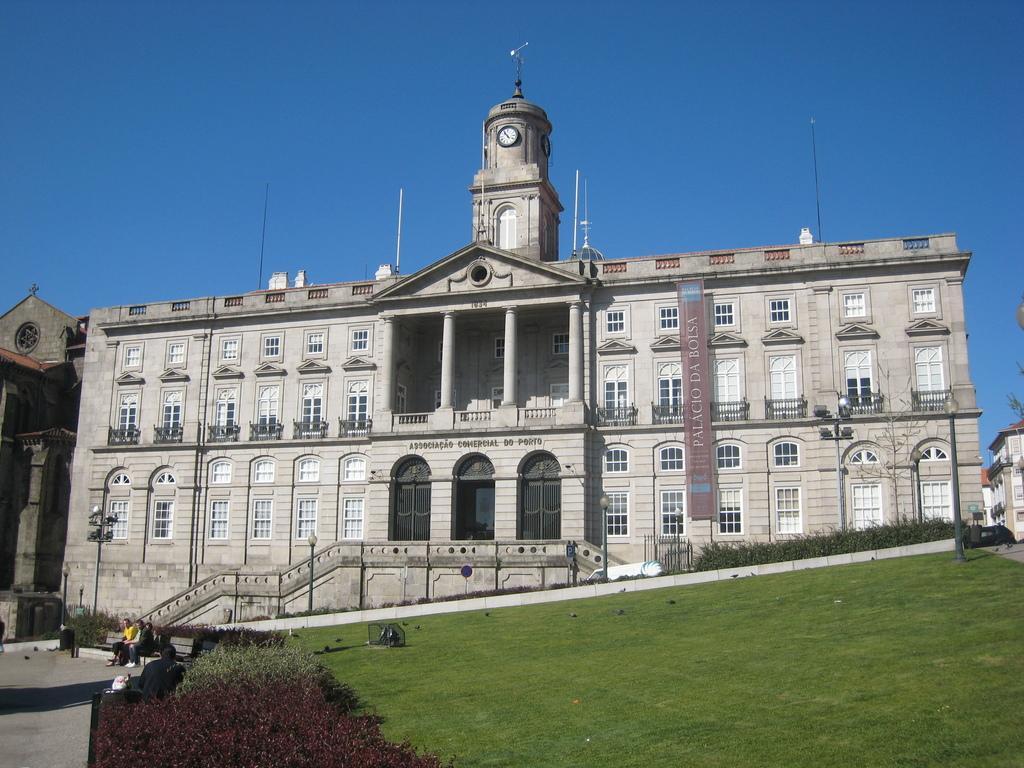Please provide a concise description of this image. In the picture I can see a building, the grass, people sitting on the bench, plants and pole lights. In the background I can see the sky. 